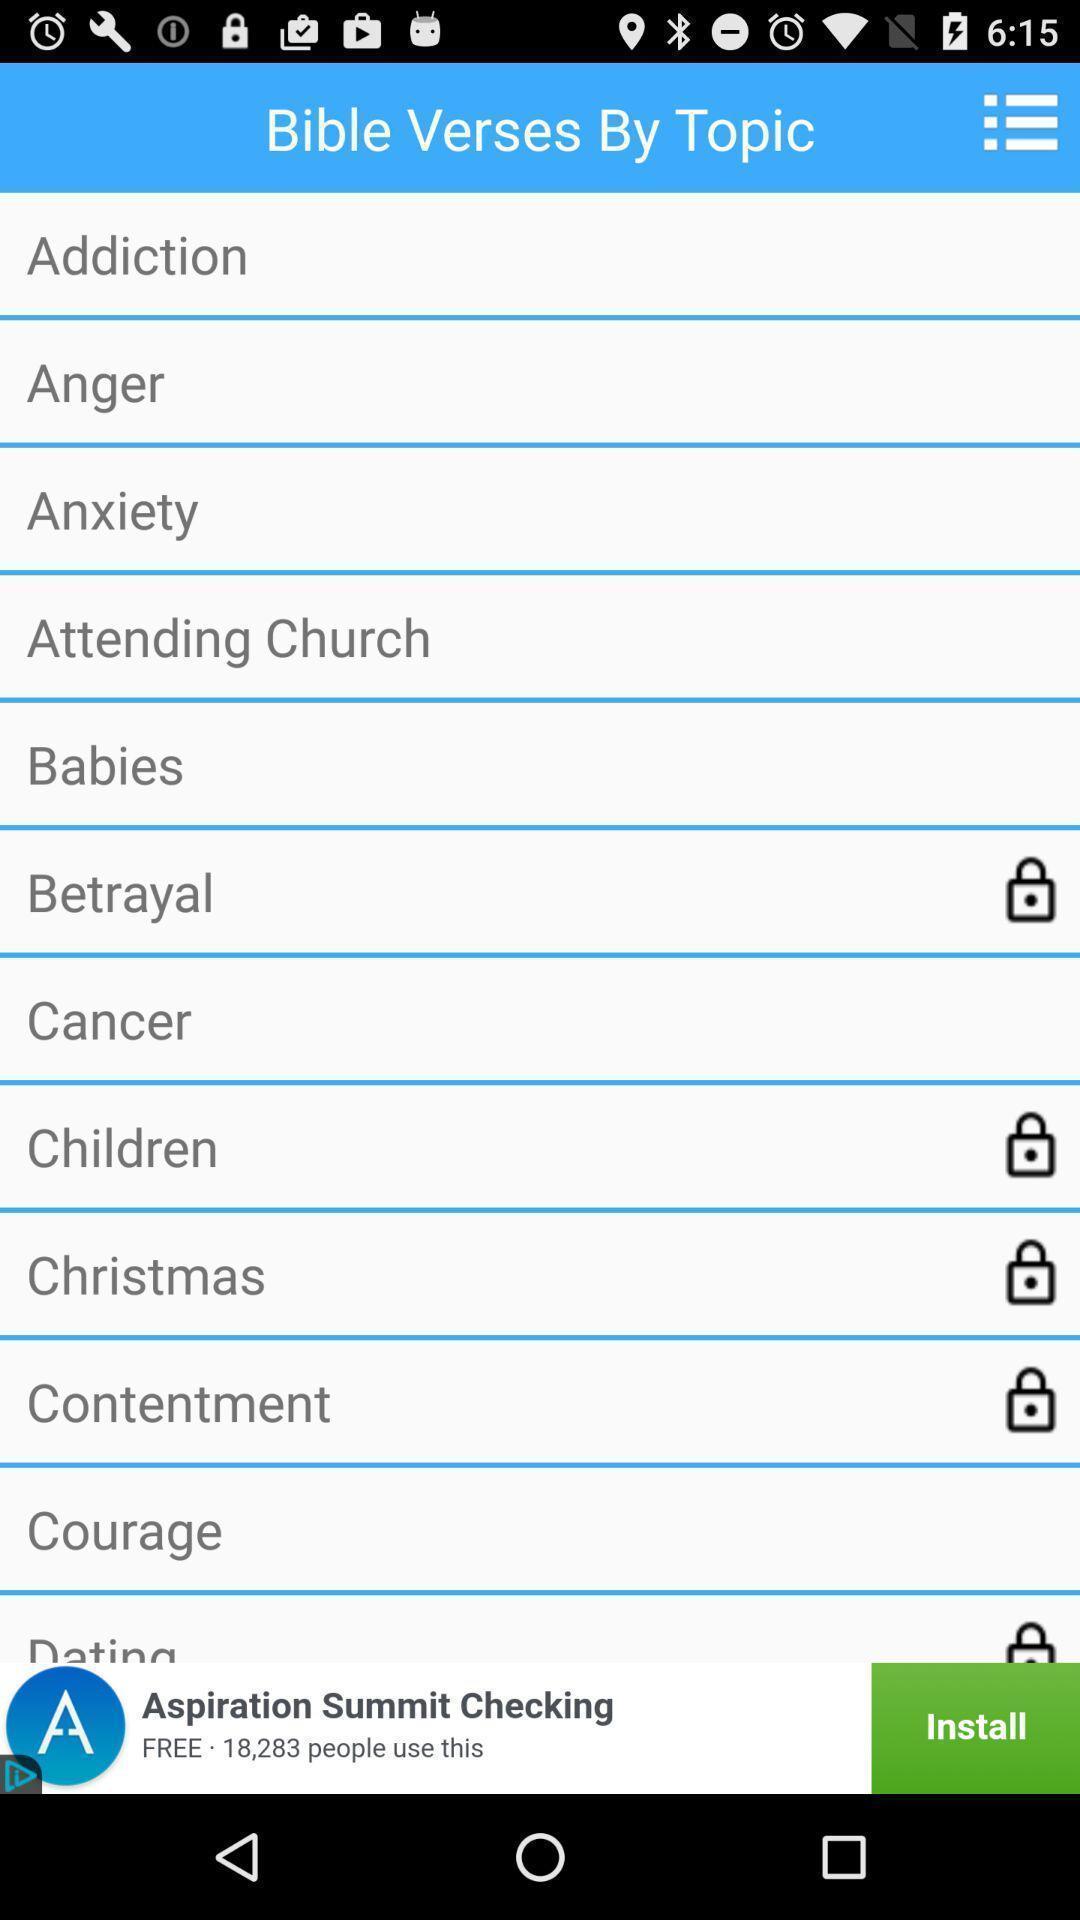Describe the content in this image. Screen showing list of topics. 